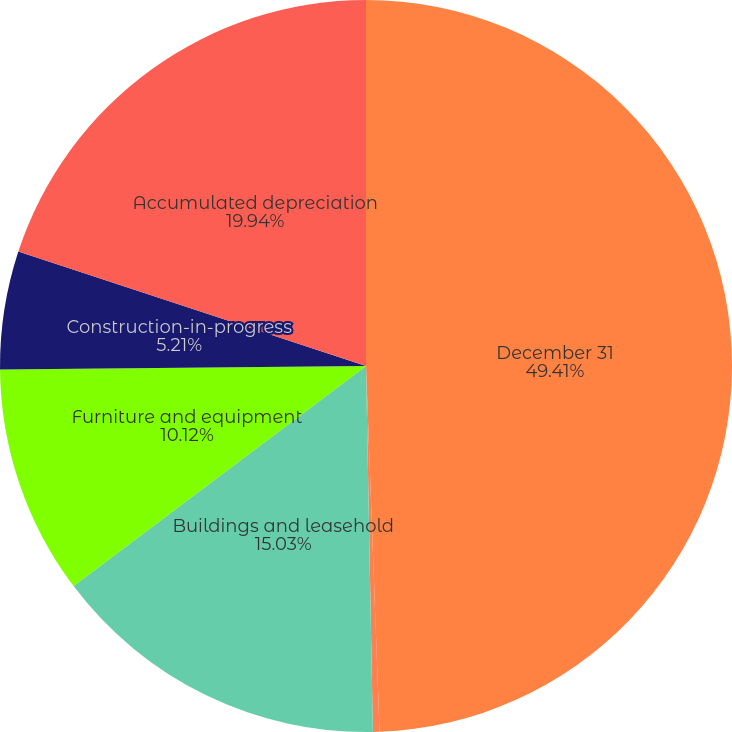Convert chart to OTSL. <chart><loc_0><loc_0><loc_500><loc_500><pie_chart><fcel>December 31<fcel>Land<fcel>Buildings and leasehold<fcel>Furniture and equipment<fcel>Construction-in-progress<fcel>Accumulated depreciation<nl><fcel>49.41%<fcel>0.29%<fcel>15.03%<fcel>10.12%<fcel>5.21%<fcel>19.94%<nl></chart> 